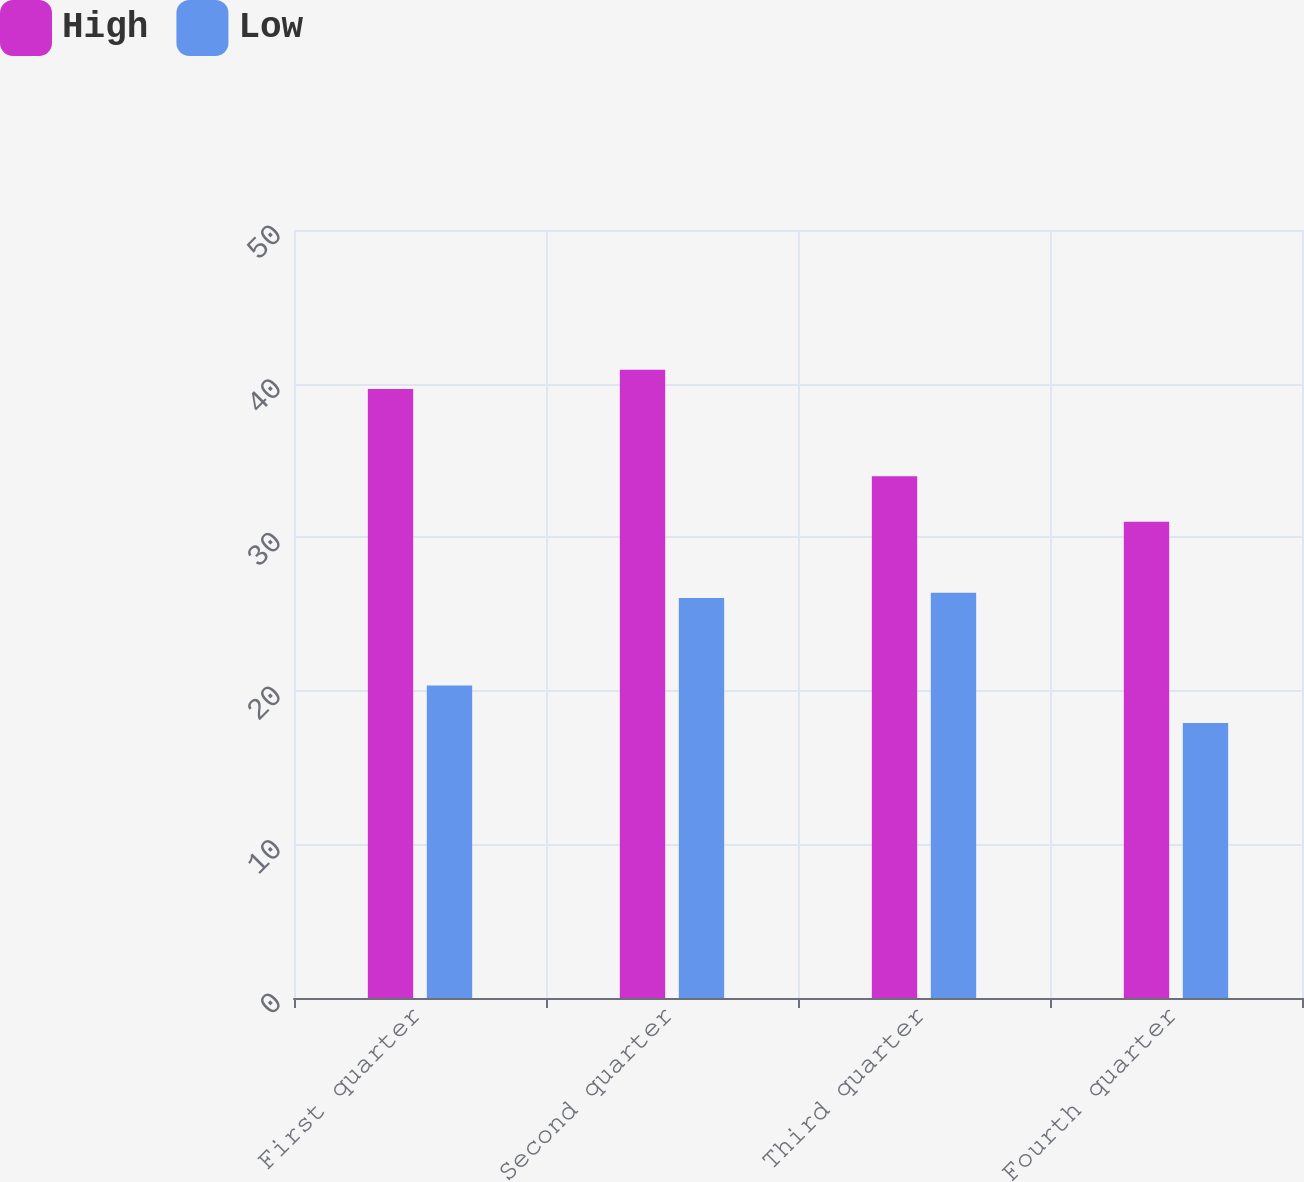Convert chart to OTSL. <chart><loc_0><loc_0><loc_500><loc_500><stacked_bar_chart><ecel><fcel>First quarter<fcel>Second quarter<fcel>Third quarter<fcel>Fourth quarter<nl><fcel>High<fcel>39.65<fcel>40.9<fcel>33.97<fcel>31<nl><fcel>Low<fcel>20.35<fcel>26.04<fcel>26.39<fcel>17.9<nl></chart> 